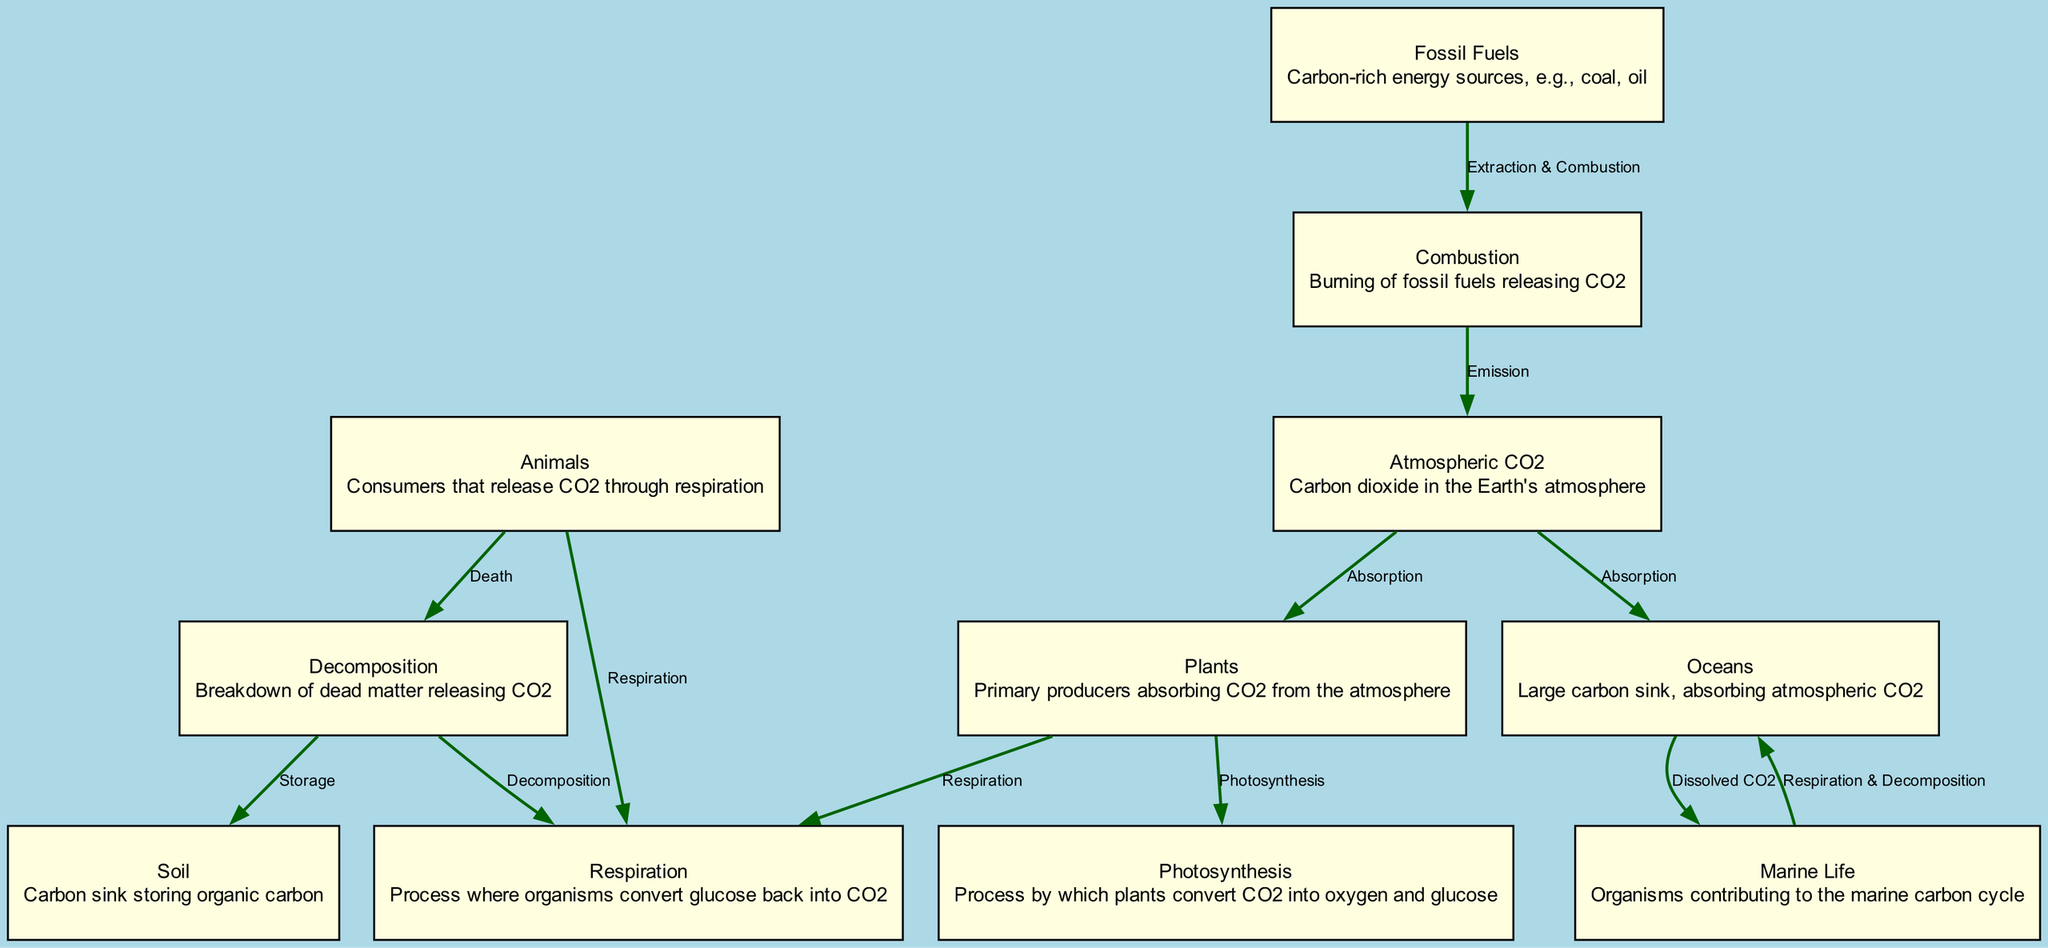What node represents carbon dioxide in the atmosphere? The diagram contains a node labeled "Atmospheric CO2," which specifically represents carbon dioxide present in the Earth's atmosphere as a key component in the carbon cycle.
Answer: Atmospheric CO2 How many processes are listed in the diagram? Upon examining the diagram, there are six distinct processes represented, including photosynthesis, respiration, decomposition, extraction & combustion, and emissions.
Answer: Six What is the result of photosynthesis in the carbon cycle? According to the diagram, the process of photosynthesis transforms carbon dioxide into oxygen and glucose, with plants being the primary producers facilitating this conversion.
Answer: Oxygen and glucose Which node acts as a carbon sink? The diagram identifies "Soil" and "Oceans" as carbon sinks, which store organic carbon and absorb atmospheric CO2, respectively.
Answer: Soil and Oceans What connects animals and respiration in the diagram? The edge labeled "Respiration" directly connects the node "Animals" to the process of "Respiration," indicating that animals release carbon dioxide through this process.
Answer: Respiration What triggers CO2 emissions in the carbon cycle? The diagram shows that the combustion of fossil fuels, indicated by the edge labeled "Emission," is the triggering event that releases carbon dioxide back into the atmosphere from the combustion process.
Answer: Combustion of fossil fuels Which process follows decomposition in the cycle? The diagram illustrates that after decomposition occurs, CO2 is released as a result of this process, which is directly linked to the respiration process that follows decomposition.
Answer: Respiration What relationship exists between oceans and marine life? The diagram demonstrates that oceans act as a carbon sink, absorbing atmospheric CO2, which marine life utilizes, indicating a mutual relationship where ocean carbon absorption supports marine organisms.
Answer: Absorption of atmospheric CO2 In total, how many edges are there in the diagram? Counting the edges in the diagram reveals that there are eleven clear connections representing various relationships and processes in the carbon cycle as depicted.
Answer: Eleven 